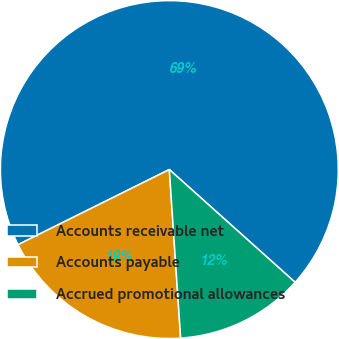Convert chart to OTSL. <chart><loc_0><loc_0><loc_500><loc_500><pie_chart><fcel>Accounts receivable net<fcel>Accounts payable<fcel>Accrued promotional allowances<nl><fcel>68.97%<fcel>18.73%<fcel>12.3%<nl></chart> 